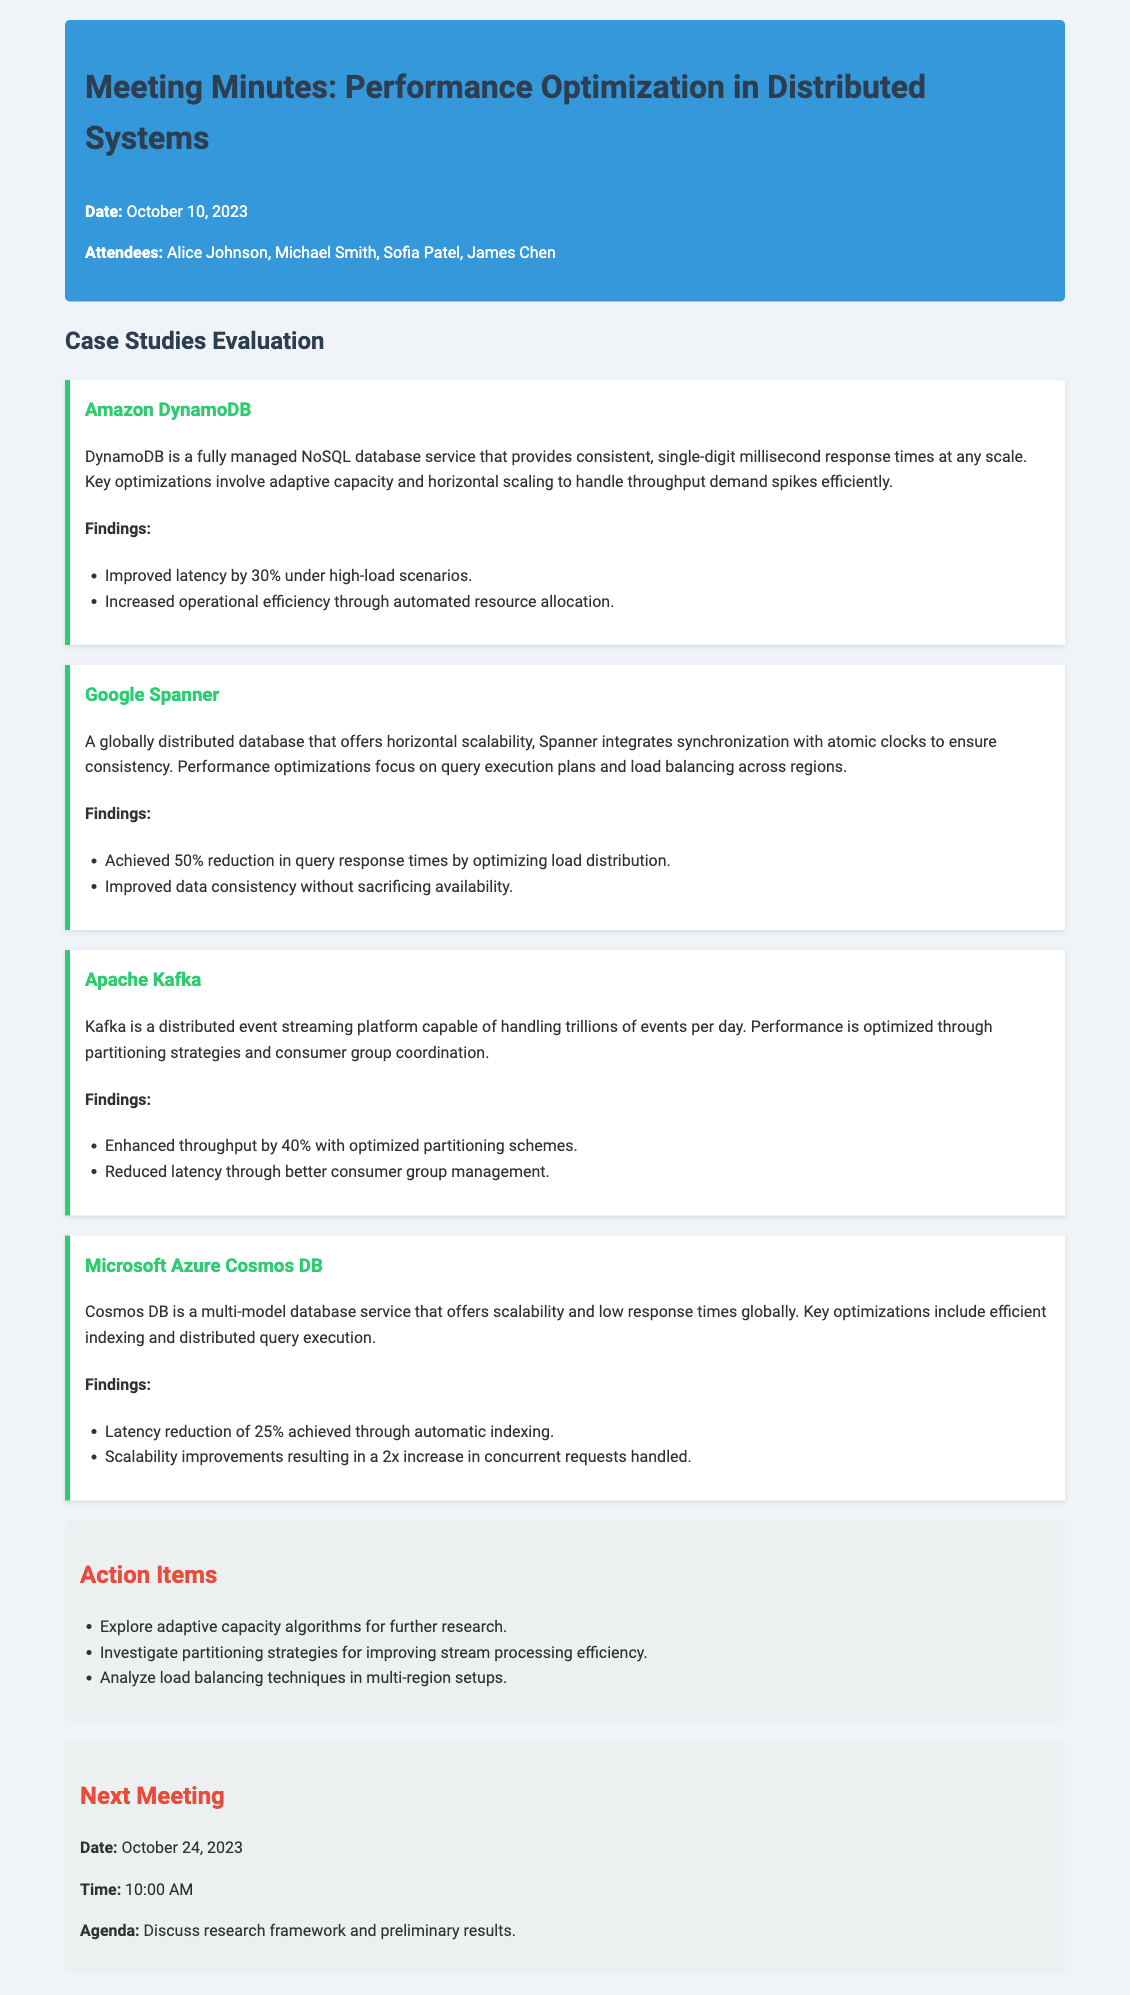What was the date of the meeting? The date is mentioned at the beginning of the document under the meeting header.
Answer: October 10, 2023 Who attended the meeting? The names of the attendees are listed in the header of the document.
Answer: Alice Johnson, Michael Smith, Sofia Patel, James Chen What is a key optimization in Amazon DynamoDB? The optimizations for DynamoDB are listed in the case study section.
Answer: Adaptive capacity and horizontal scaling What performance improvement was achieved by Google Spanner? The findings related to performance improvements are specified in the case study.
Answer: 50% reduction in query response times What action item involves algorithms? The action items are listed at the end of the document, and one specifically mentions algorithms.
Answer: Explore adaptive capacity algorithms for further research What is the next meeting date? The next meeting information is provided in the last section of the document.
Answer: October 24, 2023 How much was the latency reduced in Microsoft Azure Cosmos DB? The specific percentage of latency reduction is noted in the case study for Cosmos DB.
Answer: 25% What performance optimization strategy does Kafka utilize? The key strategies for optimization in Kafka are highlighted in the case study section.
Answer: Partitioning strategies and consumer group coordination What is the agenda for the next meeting? The agenda for the next meeting is clearly stated in the respective section.
Answer: Discuss research framework and preliminary results 